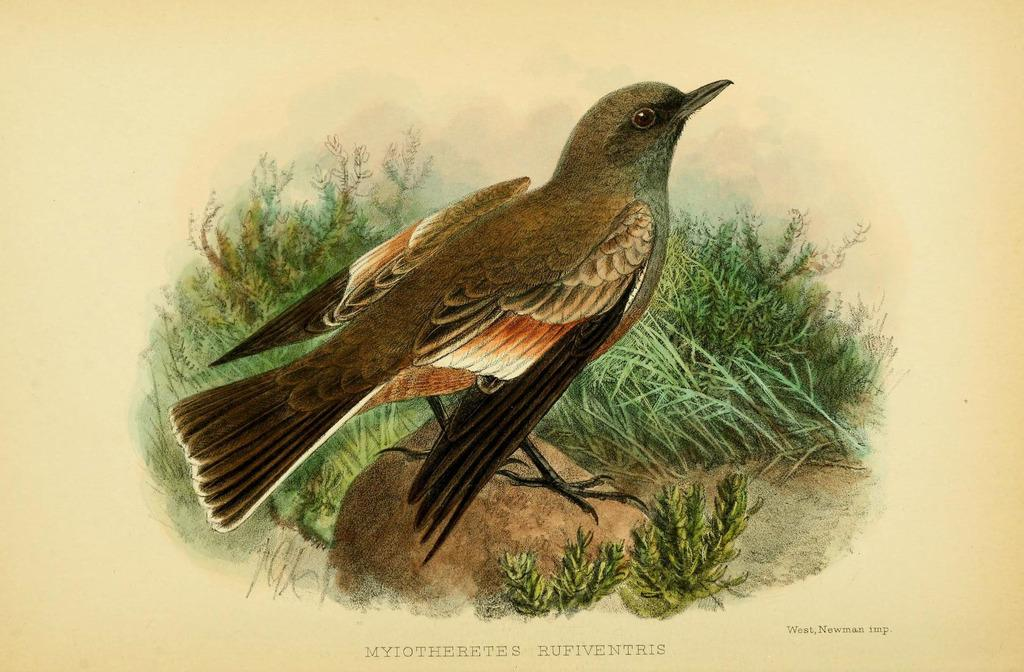What is depicted on the paper in the image? There is a painting on the paper in the image. Can you describe the painting on the paper? Unfortunately, the details of the painting cannot be determined from the provided facts. What is the primary purpose of the paper in the image? The primary purpose of the paper in the image is to serve as a canvas for the painting. How many notes are on the tray in the image? There is no tray present in the image. 